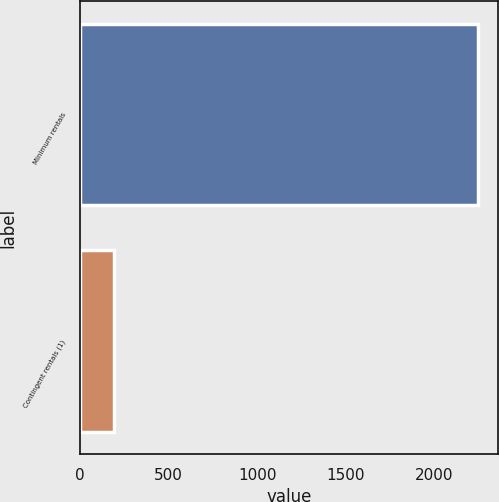Convert chart to OTSL. <chart><loc_0><loc_0><loc_500><loc_500><bar_chart><fcel>Minimum rentals<fcel>Contingent rentals (1)<nl><fcel>2249<fcel>194<nl></chart> 